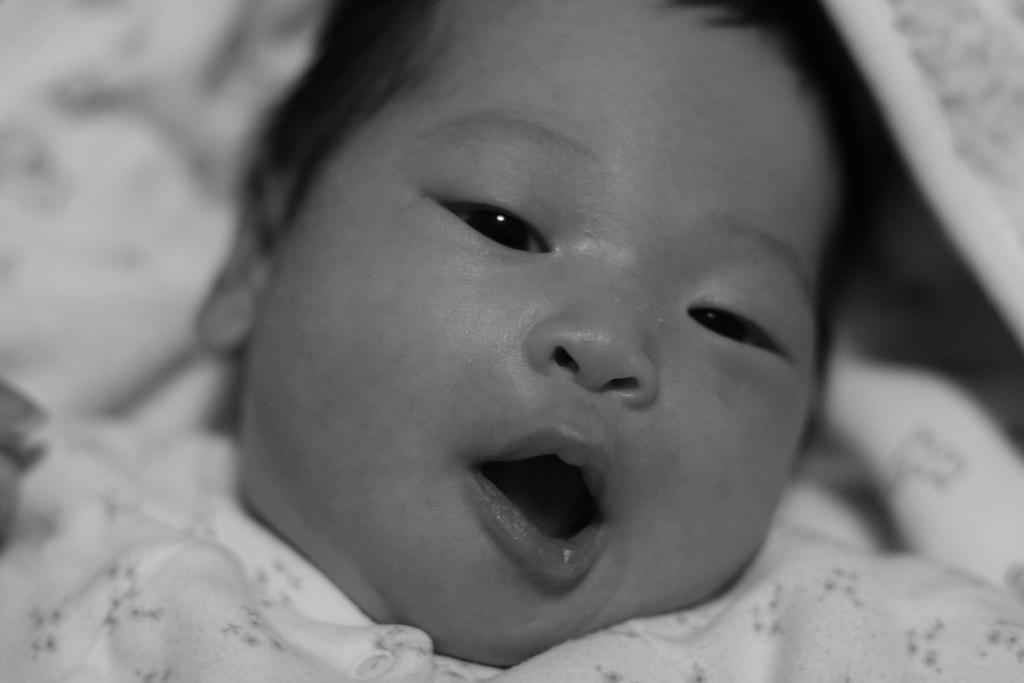What is the main subject of the image? There is a baby in the image. What is the baby lying on? The baby is lying on a cloth. What is the baby doing in the image? The baby is opening their mouth. How many cats are lying on the linen in the image? There are no cats or linen present in the image; it features a baby lying on a cloth. What type of cellar can be seen in the background of the image? There is no cellar present in the image; it features a baby lying on a cloth. 